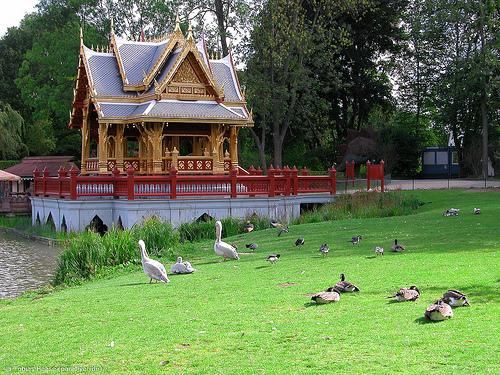Describe the vegetation and its location in the image. Tall trees are in the background, plants and tall grass are on the edge of the water, and a green-leaved tree is visible. Briefly describe the scene in the image, focusing on the birds. A group of ducks, both grey and white, are relaxing on the green grass near a body of gray water. Mention a prominent object/activity in the image and describe it briefly. There are large white ducks resting in a grassy area, some of them are sitting and some are standing. Talk about the variety of ducks in the image, focusing on their size and position. There are large and small ducks, sitting and standing in grassy areas, some lying down and some with long beaks. Discuss the presence of shadows in the image and where they are located. Shadows can be seen on the grass, especially under the large ducks sitting in the grassy area. Mention a structure in the image with details about its color and style. A small blue and white building is visible in the distance, tucked behind the trees and the gazebo. Describe the birds' appearance and their activity in the image. The birds are grey and white, some have long beaks, and they are either sitting or standing in the grass. Give a brief description of the fence and the vegetation near the water. The fence is painted red, and tall grass with reeds can be seen growing near the water's edge. Provide a short description of the main elements in the image. Ducks resting on grass, tall trees in the background, an Asian-themed house, and a small blue building are present. Describe the main architectural feature in the image and its color. There's an Asian-looking gazebo with golden columns, red fencing, and a grey and white roof. 